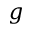Convert formula to latex. <formula><loc_0><loc_0><loc_500><loc_500>g</formula> 